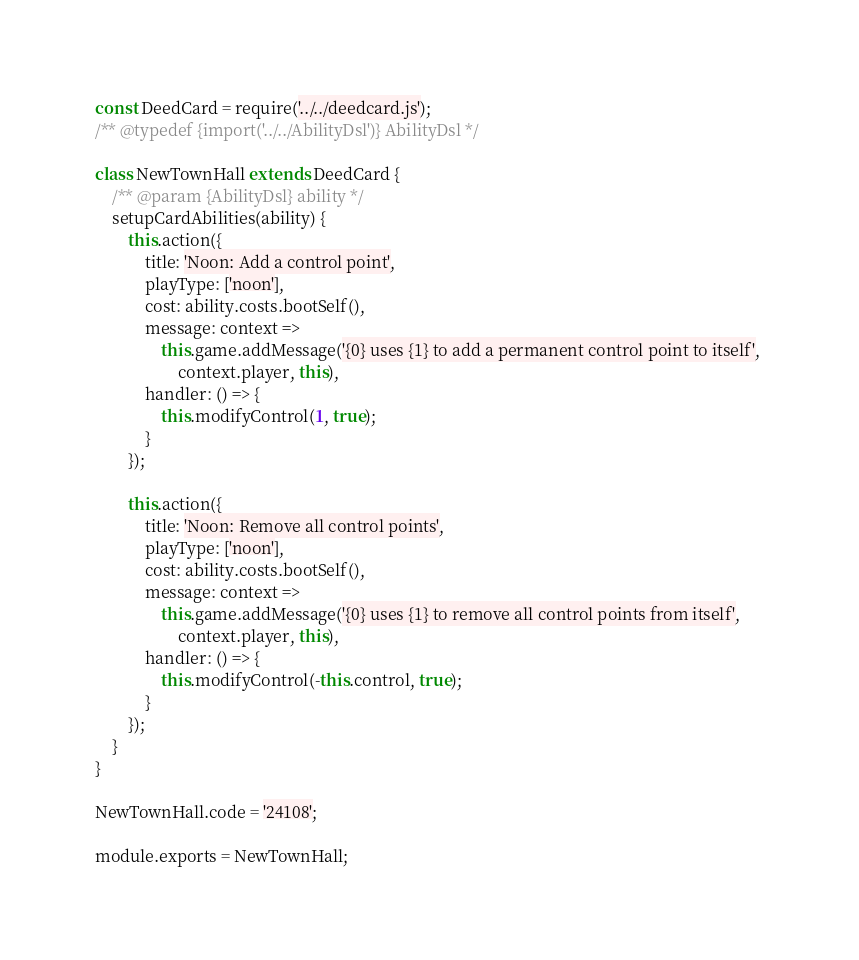Convert code to text. <code><loc_0><loc_0><loc_500><loc_500><_JavaScript_>const DeedCard = require('../../deedcard.js');
/** @typedef {import('../../AbilityDsl')} AbilityDsl */

class NewTownHall extends DeedCard {
    /** @param {AbilityDsl} ability */
    setupCardAbilities(ability) {
        this.action({
            title: 'Noon: Add a control point',
            playType: ['noon'],
            cost: ability.costs.bootSelf(),
            message: context => 
                this.game.addMessage('{0} uses {1} to add a permanent control point to itself', 
                    context.player, this),
            handler: () => {
                this.modifyControl(1, true);
            }
        });

        this.action({
            title: 'Noon: Remove all control points',
            playType: ['noon'],
            cost: ability.costs.bootSelf(),
            message: context => 
                this.game.addMessage('{0} uses {1} to remove all control points from itself', 
                    context.player, this),
            handler: () => {
                this.modifyControl(-this.control, true);
            }
        });
    }
}

NewTownHall.code = '24108';

module.exports = NewTownHall;
</code> 